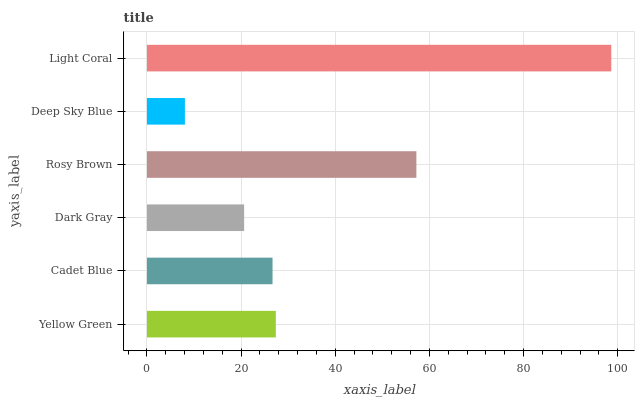Is Deep Sky Blue the minimum?
Answer yes or no. Yes. Is Light Coral the maximum?
Answer yes or no. Yes. Is Cadet Blue the minimum?
Answer yes or no. No. Is Cadet Blue the maximum?
Answer yes or no. No. Is Yellow Green greater than Cadet Blue?
Answer yes or no. Yes. Is Cadet Blue less than Yellow Green?
Answer yes or no. Yes. Is Cadet Blue greater than Yellow Green?
Answer yes or no. No. Is Yellow Green less than Cadet Blue?
Answer yes or no. No. Is Yellow Green the high median?
Answer yes or no. Yes. Is Cadet Blue the low median?
Answer yes or no. Yes. Is Cadet Blue the high median?
Answer yes or no. No. Is Deep Sky Blue the low median?
Answer yes or no. No. 